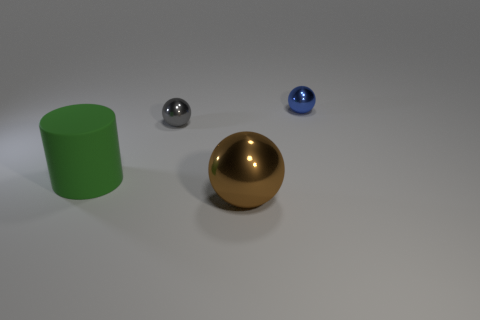Subtract all tiny metal spheres. How many spheres are left? 1 Subtract all balls. How many objects are left? 1 Subtract all gray balls. How many balls are left? 2 Add 3 big purple metallic cylinders. How many big purple metallic cylinders exist? 3 Add 1 purple metal cylinders. How many objects exist? 5 Subtract 1 blue spheres. How many objects are left? 3 Subtract 1 spheres. How many spheres are left? 2 Subtract all yellow cylinders. Subtract all blue balls. How many cylinders are left? 1 Subtract all red blocks. How many brown spheres are left? 1 Subtract all big matte cylinders. Subtract all large rubber cylinders. How many objects are left? 2 